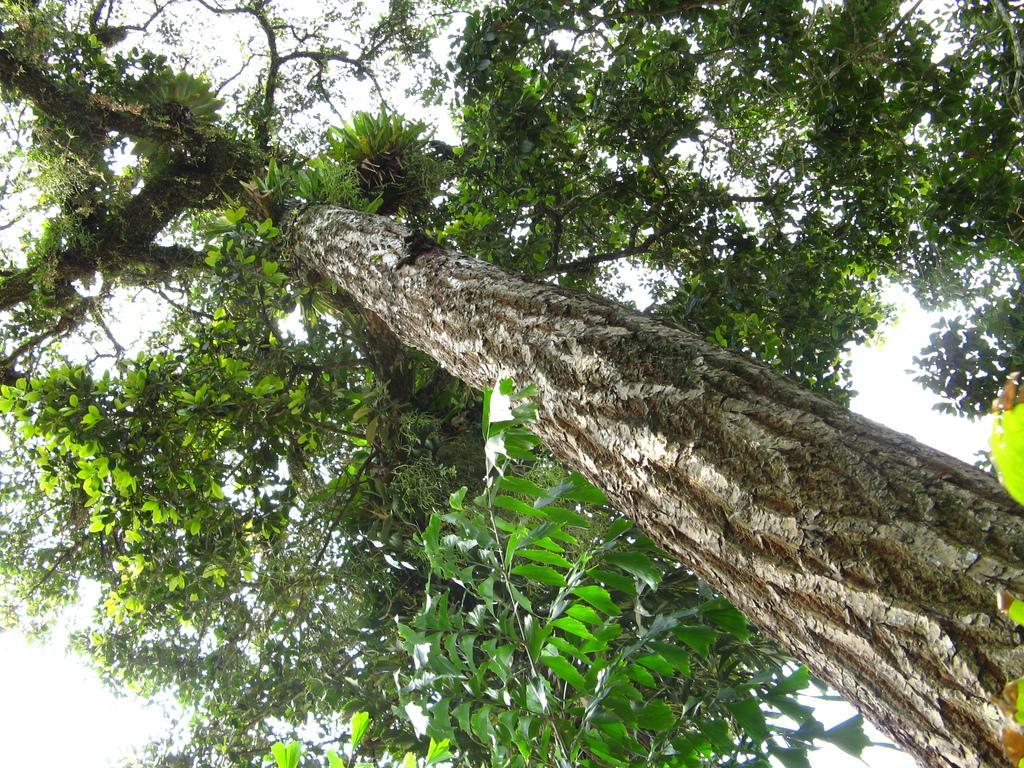In one or two sentences, can you explain what this image depicts? In this picture we can see a tree in the front, we can see the sky in the background. 